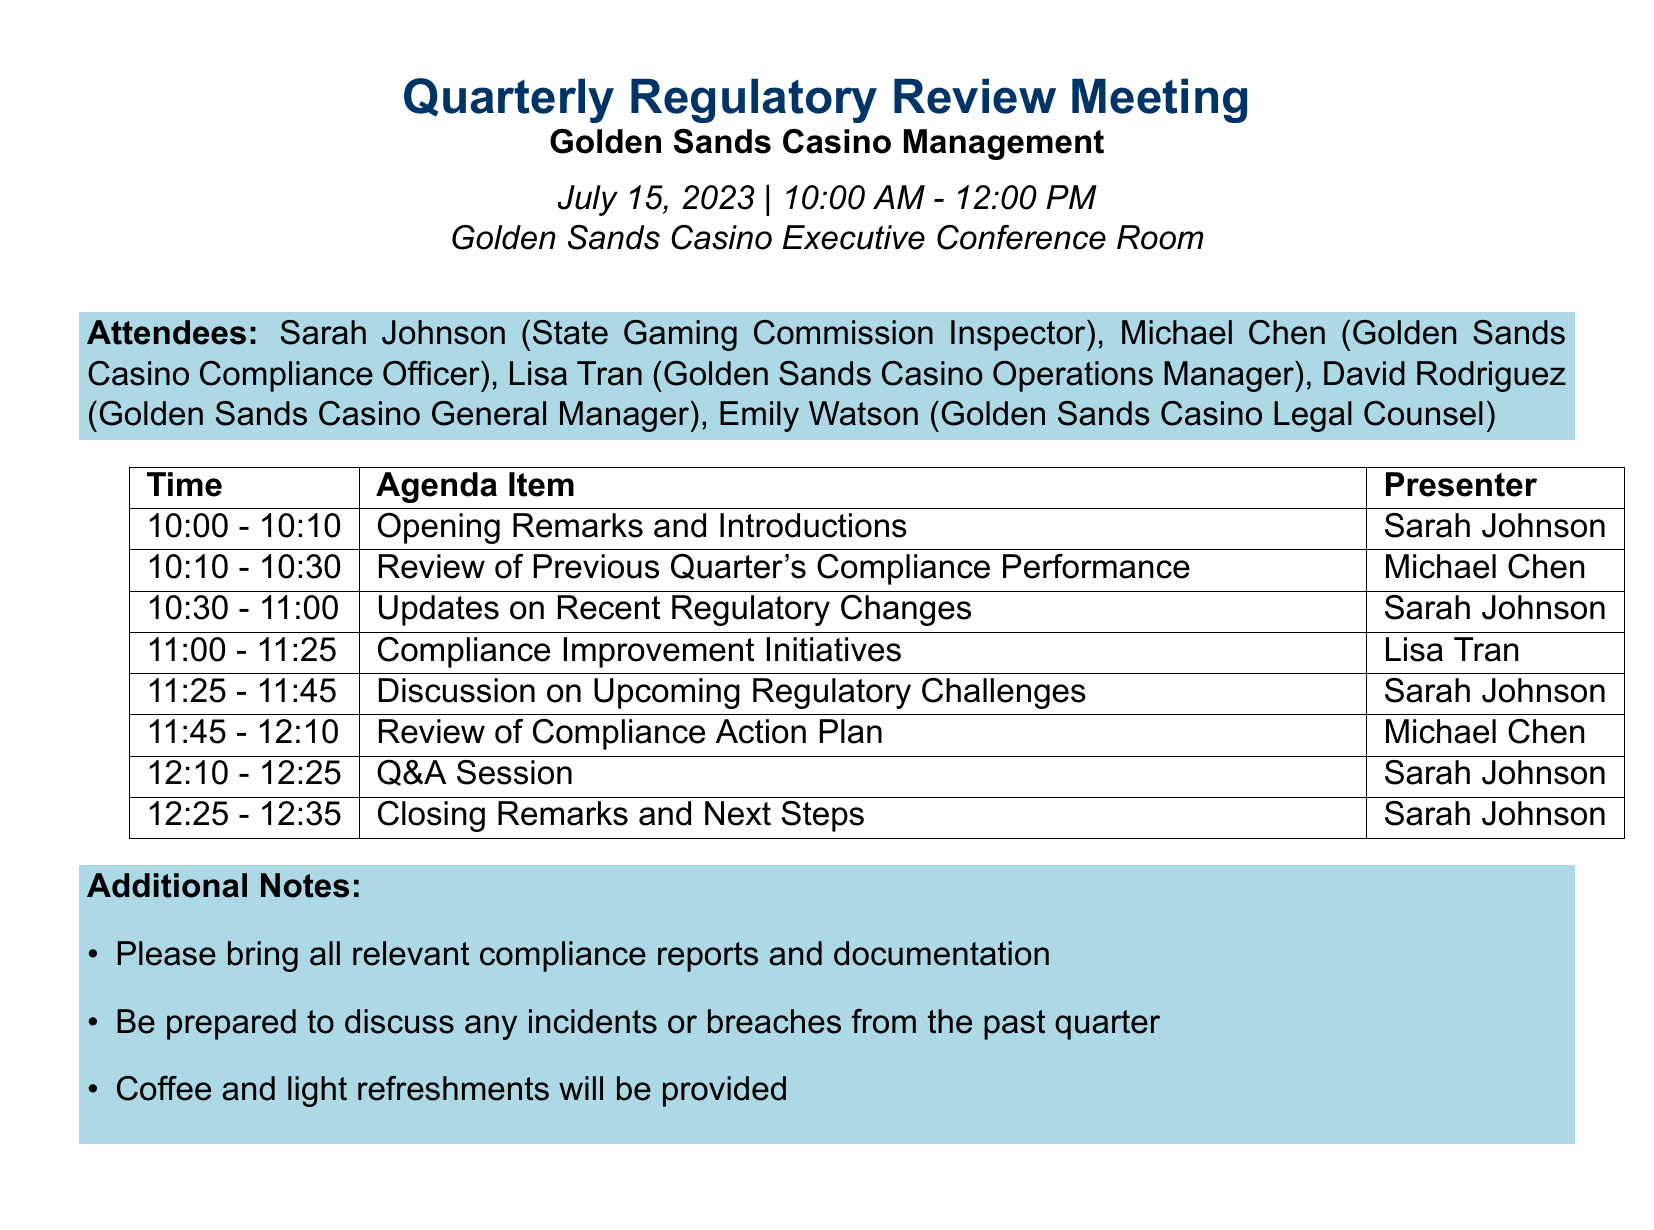What is the title of the meeting? The title of the meeting is mentioned in the meeting details section of the document.
Answer: Quarterly Regulatory Review Meeting with Golden Sands Casino Management Who is the facilitator for the Q&A session? The facilitator for the Q&A session is indicated in the agenda item for that session.
Answer: Sarah Johnson What is the duration of the Compliance Improvement Initiatives agenda item? The duration of the agenda item can be found in the corresponding entry in the agenda section.
Answer: 25 minutes What are the key points in the Updates on Recent Regulatory Changes? The key points are listed under the agenda item for Updates on Recent Regulatory Changes, requiring a brief review of them.
Answer: New anti-money laundering (AML) reporting requirements, Changes to problem gambling intervention protocols, Updated guidelines for electronic gaming machine (EGM) testing and certification What is the location of the meeting? The location is specified in the meeting details section, providing a specific place for the meeting.
Answer: Golden Sands Casino Executive Conference Room 